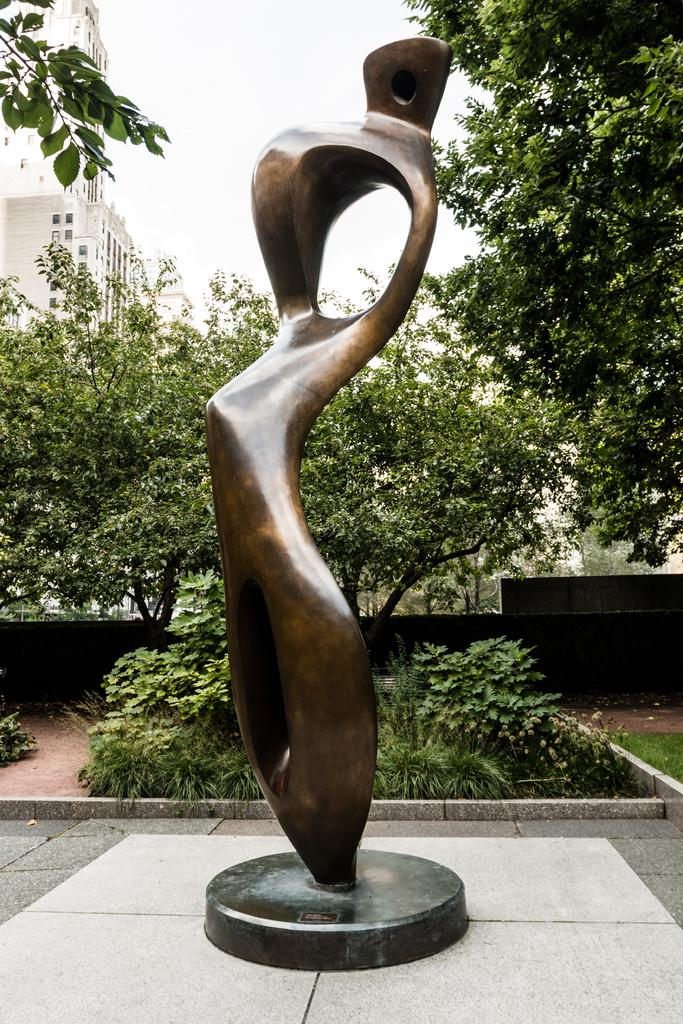What is the main subject in the middle of the image? There is a statue in the middle of the image. What can be seen in the background of the image? There are trees and buildings in the background of the image. What is visible at the top of the image? The sky is visible at the top of the image. What type of secretary can be seen working near the statue in the image? There is no secretary present in the image; it only features a statue, trees, buildings, and the sky. What tool is the statue using to hammer in the image? The statue is not using any tool, such as a hammer, in the image. 